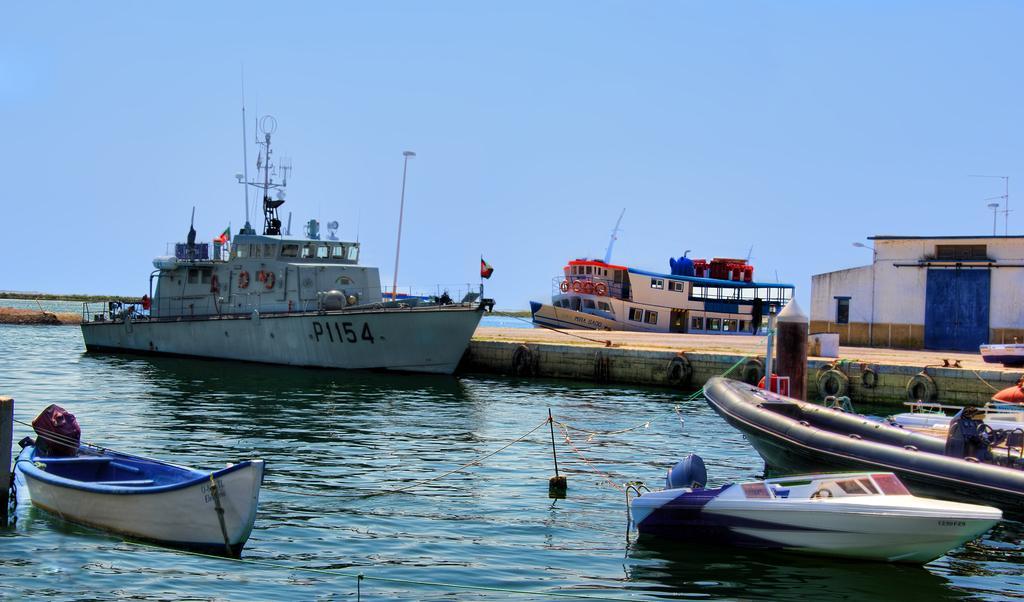Could you give a brief overview of what you see in this image? In this picture we can see the ships and boats on the water. On the right there is a house, beside that we can see poles and street lights. At the bottom we can see the water. At the top there is a sky. In the background we can see many trees. On the left we can see the ship on that there is a flag, poles and other objects. 